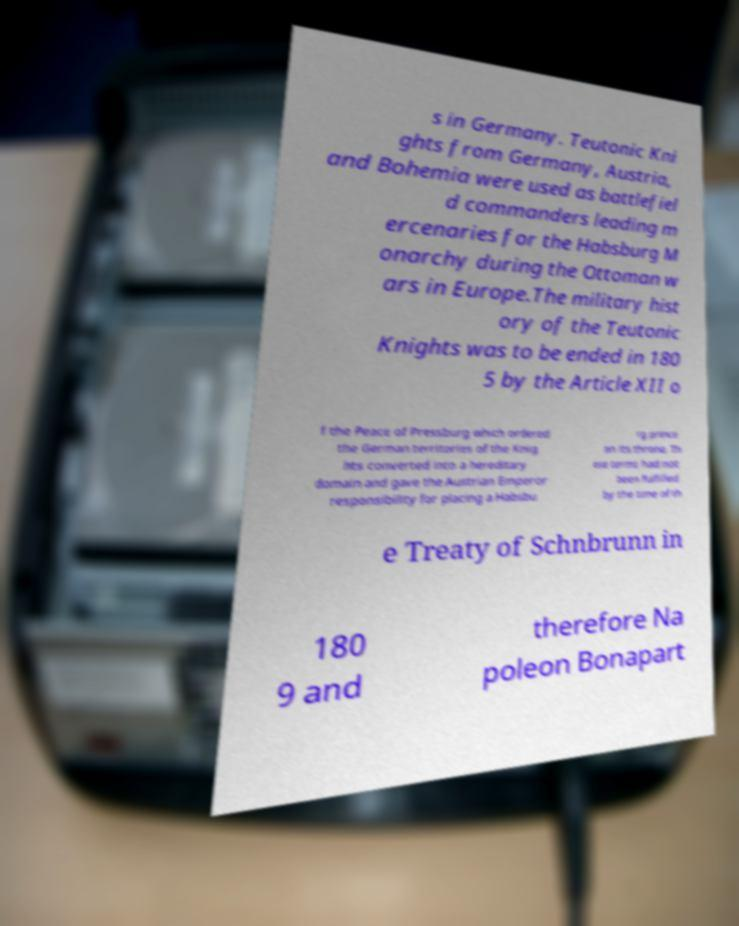Please read and relay the text visible in this image. What does it say? s in Germany. Teutonic Kni ghts from Germany, Austria, and Bohemia were used as battlefiel d commanders leading m ercenaries for the Habsburg M onarchy during the Ottoman w ars in Europe.The military hist ory of the Teutonic Knights was to be ended in 180 5 by the Article XII o f the Peace of Pressburg which ordered the German territories of the Knig hts converted into a hereditary domain and gave the Austrian Emperor responsibility for placing a Habsbu rg prince on its throne. Th ese terms had not been fulfilled by the time of th e Treaty of Schnbrunn in 180 9 and therefore Na poleon Bonapart 